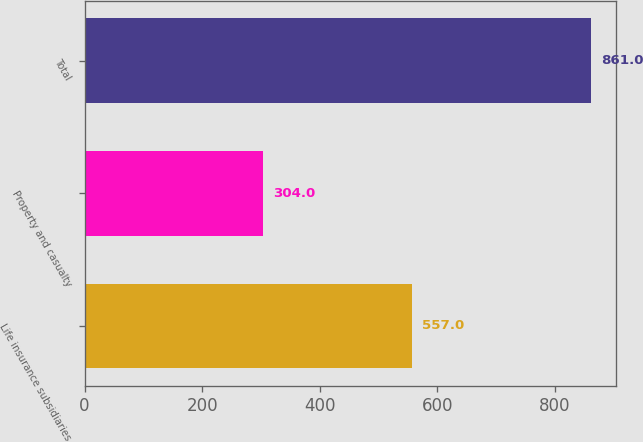Convert chart to OTSL. <chart><loc_0><loc_0><loc_500><loc_500><bar_chart><fcel>Life insurance subsidiaries<fcel>Property and casualty<fcel>Total<nl><fcel>557<fcel>304<fcel>861<nl></chart> 